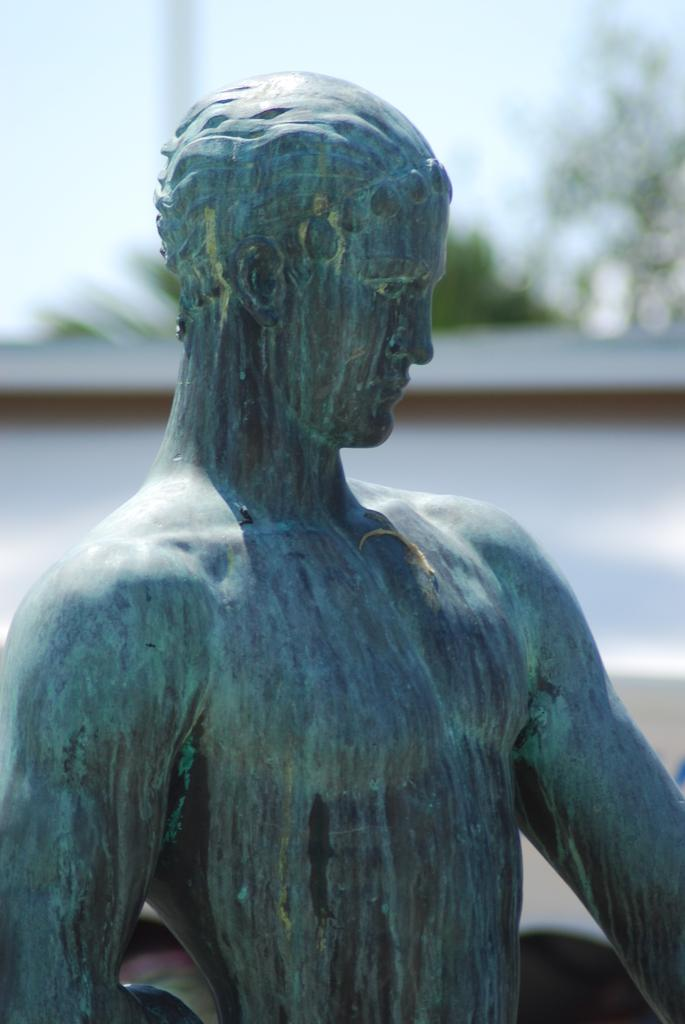What is the main subject in the image? There is a statue in the image. What can be seen in the background of the image? There is a white color wall, trees, and the sky visible in the background of the image. How many potatoes are on the statue in the image? There are no potatoes present on the statue in the image. What time does the clock on the statue show in the image? There is no clock present on the statue in the image. 